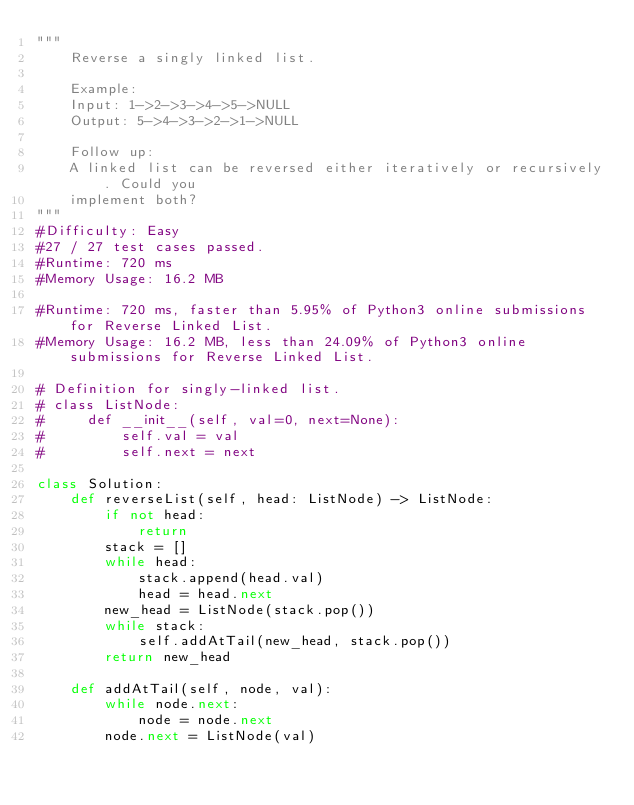<code> <loc_0><loc_0><loc_500><loc_500><_Python_>"""
    Reverse a singly linked list.

    Example:
    Input: 1->2->3->4->5->NULL
    Output: 5->4->3->2->1->NULL

    Follow up:
    A linked list can be reversed either iteratively or recursively. Could you 
    implement both?
"""
#Difficulty: Easy
#27 / 27 test cases passed.
#Runtime: 720 ms
#Memory Usage: 16.2 MB

#Runtime: 720 ms, faster than 5.95% of Python3 online submissions for Reverse Linked List.
#Memory Usage: 16.2 MB, less than 24.09% of Python3 online submissions for Reverse Linked List.

# Definition for singly-linked list.
# class ListNode:
#     def __init__(self, val=0, next=None):
#         self.val = val
#         self.next = next

class Solution:
    def reverseList(self, head: ListNode) -> ListNode:
        if not head:
            return
        stack = []
        while head:
            stack.append(head.val)
            head = head.next
        new_head = ListNode(stack.pop())
        while stack:
            self.addAtTail(new_head, stack.pop())
        return new_head

    def addAtTail(self, node, val):
        while node.next:
            node = node.next
        node.next = ListNode(val)
</code> 